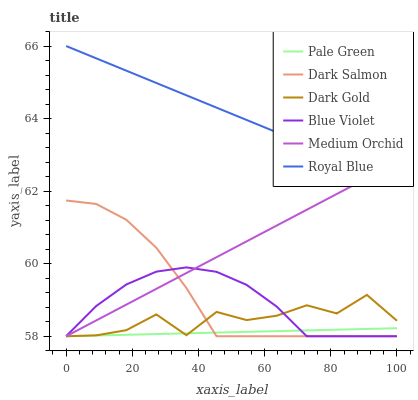Does Pale Green have the minimum area under the curve?
Answer yes or no. Yes. Does Royal Blue have the maximum area under the curve?
Answer yes or no. Yes. Does Medium Orchid have the minimum area under the curve?
Answer yes or no. No. Does Medium Orchid have the maximum area under the curve?
Answer yes or no. No. Is Medium Orchid the smoothest?
Answer yes or no. Yes. Is Dark Gold the roughest?
Answer yes or no. Yes. Is Dark Salmon the smoothest?
Answer yes or no. No. Is Dark Salmon the roughest?
Answer yes or no. No. Does Dark Gold have the lowest value?
Answer yes or no. Yes. Does Royal Blue have the lowest value?
Answer yes or no. No. Does Royal Blue have the highest value?
Answer yes or no. Yes. Does Medium Orchid have the highest value?
Answer yes or no. No. Is Dark Gold less than Royal Blue?
Answer yes or no. Yes. Is Royal Blue greater than Pale Green?
Answer yes or no. Yes. Does Dark Salmon intersect Pale Green?
Answer yes or no. Yes. Is Dark Salmon less than Pale Green?
Answer yes or no. No. Is Dark Salmon greater than Pale Green?
Answer yes or no. No. Does Dark Gold intersect Royal Blue?
Answer yes or no. No. 